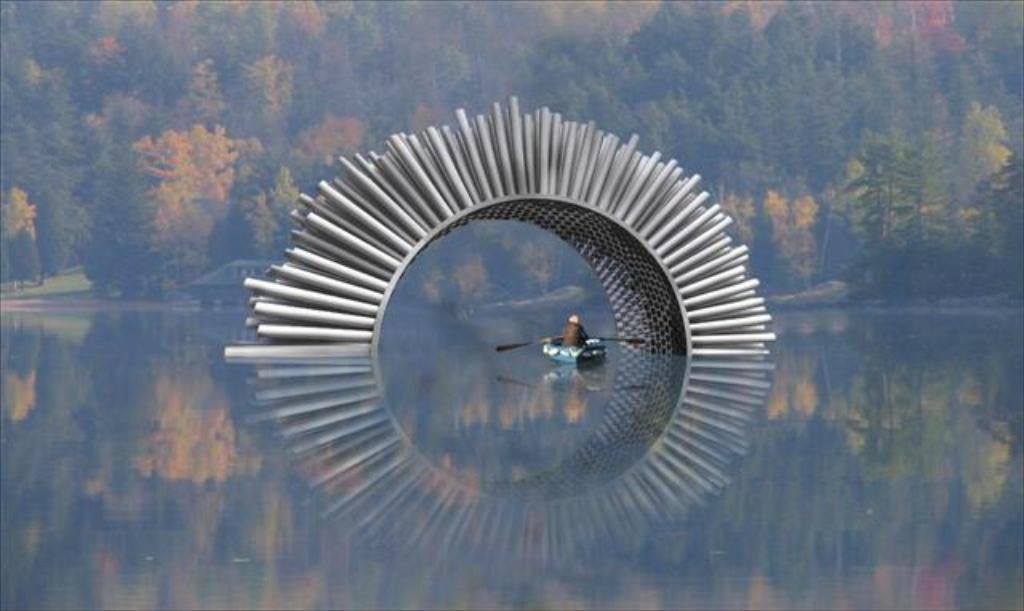What is the main feature in the water in the image? There is an arch in the water. What is the person in the image doing? The person is on a boat. What can be seen in the background of the image? There are trees visible in the distance. What type of guitar is the tramp playing on the boat in the image? There is no tramp or guitar present in the image. The person is simply on a boat, and there is no mention of a guitar or any musical activity. 